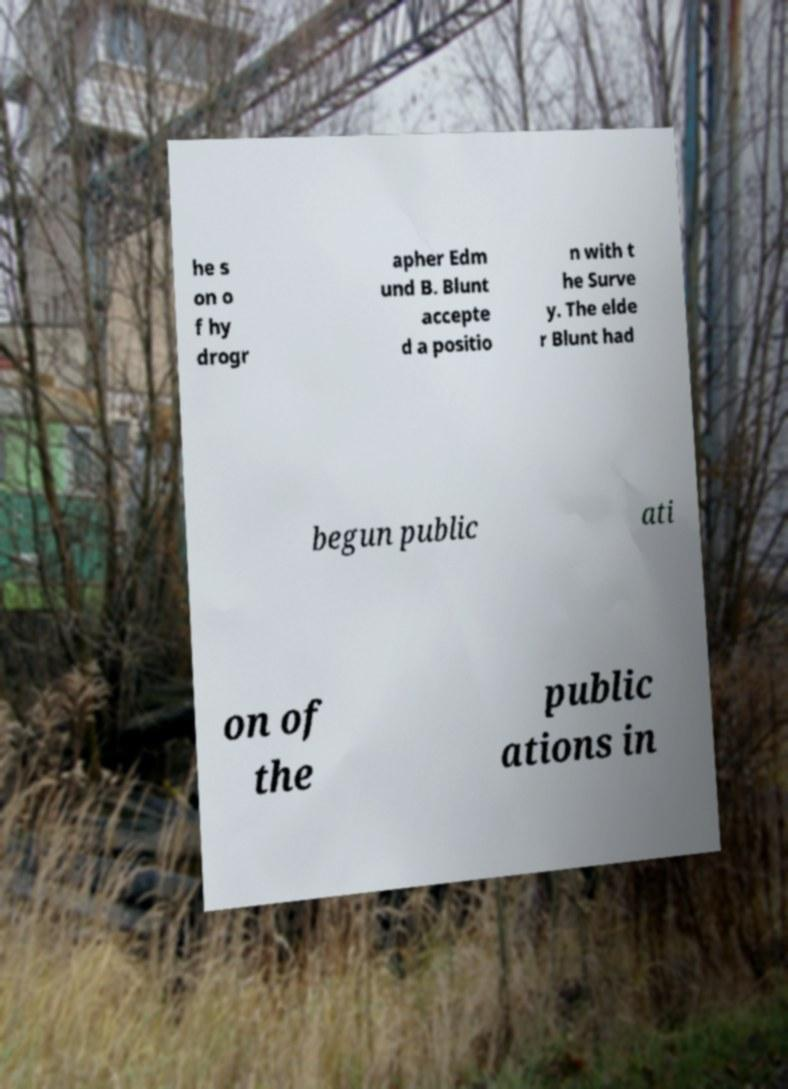Can you accurately transcribe the text from the provided image for me? he s on o f hy drogr apher Edm und B. Blunt accepte d a positio n with t he Surve y. The elde r Blunt had begun public ati on of the public ations in 